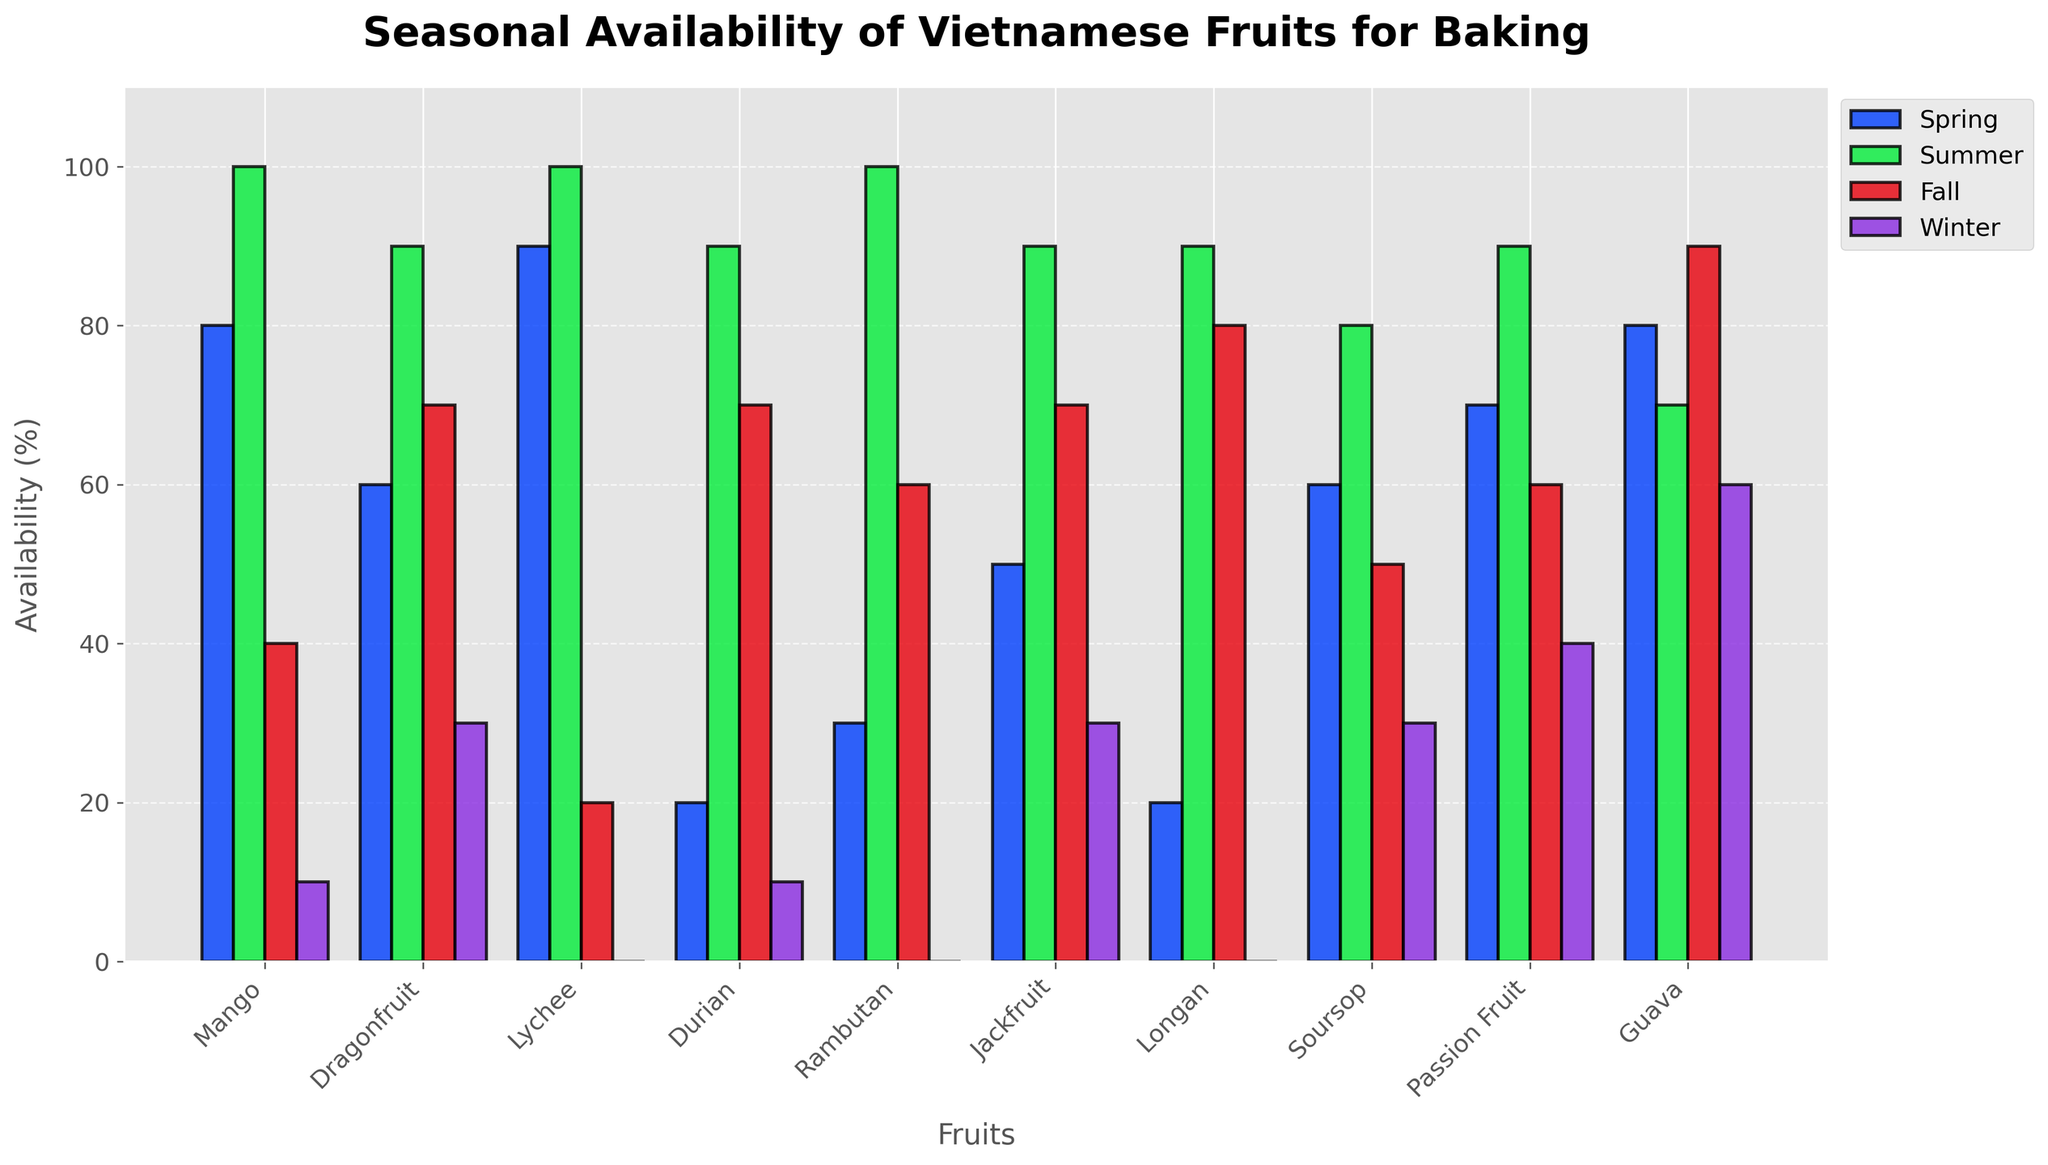Which fruit has the highest availability in Summer? By looking at the height of the bars for the Summer season, the Mango, Lychee, Rambutan, and Longan all have bars that reach 100% availability.
Answer: Mango, Lychee, Rambutan, Longan Which fruit shows the least availability in Winter? By comparing the height of all Winter season bars, Lychee and Rambutan have bars reaching 0%, making them the least available.
Answer: Lychee, Rambutan What is the average availability of Dragonfruit across all seasons? Add up the heights of the Dragonfruit bars across all seasons: 60 (Spring) + 90 (Summer) + 70 (Fall) + 30 (Winter) = 250. Then divide by the number of seasons (4).
Answer: 62.5 Between Passion Fruit and Guava, which fruit is more consistently available across all seasons? Examine the heights of the bars for Passion Fruit and Guava. Both have varying heights but Guava has more uniform availability with bars reaching: 80 (Spring), 70 (Summer), 90 (Fall), 60 (Winter). In comparison, Passion Fruit has greater variability among its bars: 70 (Spring), 90 (Summer), 60 (Fall), 40 (Winter).
Answer: Guava If you were to choose a fruit with high availability in both Spring and Fall only, which fruit would you choose? Compare the heights of bars for all fruits in Spring and Fall. Look for fruits with relatively high bars in both seasons. Mango (80% Spring, 40% Fall) or Guava (80% Spring, 90% Fall) could be good choices, with Guava having higher availability in Fall.
Answer: Guava What is the combined availability of Mangos and Lychees in Spring? Sum the height of bars for Mango in Spring (80) and Lychee in Spring (90).
Answer: 170 Which season shows the most uniform availability of fruits overall? Judging by the uniformity in bar heights across all fruits, Spring seems to show more equal heights, indicating a more balanced availability.
Answer: Spring 